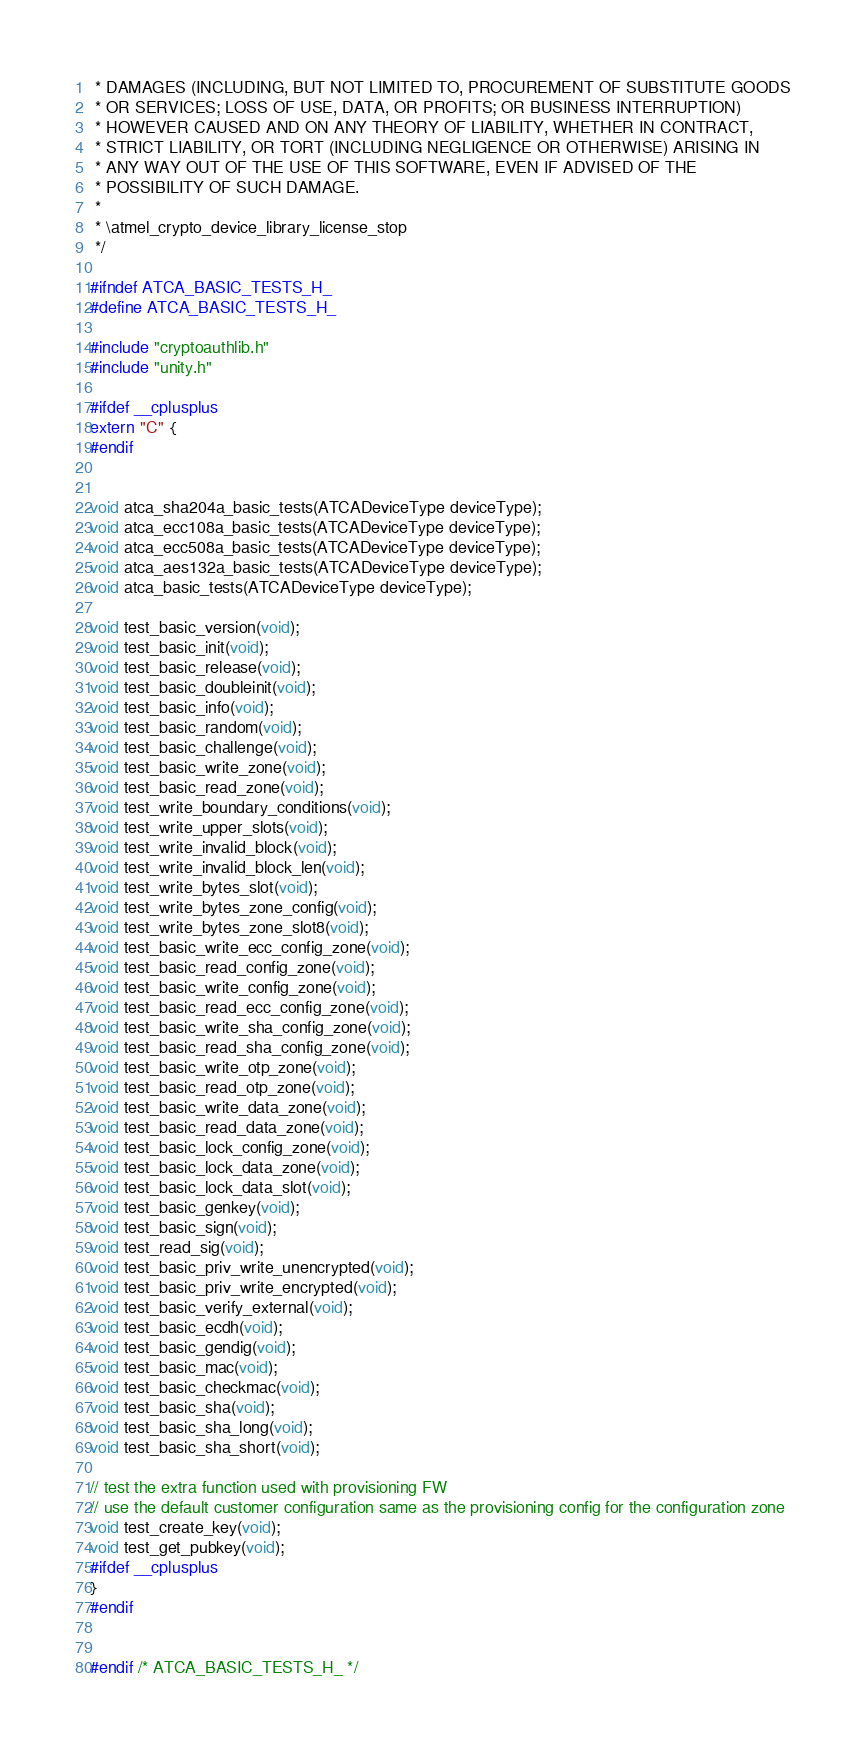<code> <loc_0><loc_0><loc_500><loc_500><_C_> * DAMAGES (INCLUDING, BUT NOT LIMITED TO, PROCUREMENT OF SUBSTITUTE GOODS
 * OR SERVICES; LOSS OF USE, DATA, OR PROFITS; OR BUSINESS INTERRUPTION)
 * HOWEVER CAUSED AND ON ANY THEORY OF LIABILITY, WHETHER IN CONTRACT,
 * STRICT LIABILITY, OR TORT (INCLUDING NEGLIGENCE OR OTHERWISE) ARISING IN
 * ANY WAY OUT OF THE USE OF THIS SOFTWARE, EVEN IF ADVISED OF THE
 * POSSIBILITY OF SUCH DAMAGE.
 *
 * \atmel_crypto_device_library_license_stop
 */

#ifndef ATCA_BASIC_TESTS_H_
#define ATCA_BASIC_TESTS_H_

#include "cryptoauthlib.h"
#include "unity.h"

#ifdef __cplusplus
extern "C" {
#endif


void atca_sha204a_basic_tests(ATCADeviceType deviceType);
void atca_ecc108a_basic_tests(ATCADeviceType deviceType);
void atca_ecc508a_basic_tests(ATCADeviceType deviceType);
void atca_aes132a_basic_tests(ATCADeviceType deviceType);
void atca_basic_tests(ATCADeviceType deviceType);

void test_basic_version(void);
void test_basic_init(void);
void test_basic_release(void);
void test_basic_doubleinit(void);
void test_basic_info(void);
void test_basic_random(void);
void test_basic_challenge(void);
void test_basic_write_zone(void);
void test_basic_read_zone(void);
void test_write_boundary_conditions(void);
void test_write_upper_slots(void);
void test_write_invalid_block(void);
void test_write_invalid_block_len(void);
void test_write_bytes_slot(void);
void test_write_bytes_zone_config(void);
void test_write_bytes_zone_slot8(void);
void test_basic_write_ecc_config_zone(void);
void test_basic_read_config_zone(void);
void test_basic_write_config_zone(void);
void test_basic_read_ecc_config_zone(void);
void test_basic_write_sha_config_zone(void);
void test_basic_read_sha_config_zone(void);
void test_basic_write_otp_zone(void);
void test_basic_read_otp_zone(void);
void test_basic_write_data_zone(void);
void test_basic_read_data_zone(void);
void test_basic_lock_config_zone(void);
void test_basic_lock_data_zone(void);
void test_basic_lock_data_slot(void);
void test_basic_genkey(void);
void test_basic_sign(void);
void test_read_sig(void);
void test_basic_priv_write_unencrypted(void);
void test_basic_priv_write_encrypted(void);
void test_basic_verify_external(void);
void test_basic_ecdh(void);
void test_basic_gendig(void);
void test_basic_mac(void);
void test_basic_checkmac(void);
void test_basic_sha(void);
void test_basic_sha_long(void);
void test_basic_sha_short(void);

// test the extra function used with provisioning FW
// use the default customer configuration same as the provisioning config for the configuration zone
void test_create_key(void);
void test_get_pubkey(void);
#ifdef __cplusplus
}
#endif


#endif /* ATCA_BASIC_TESTS_H_ */
</code> 